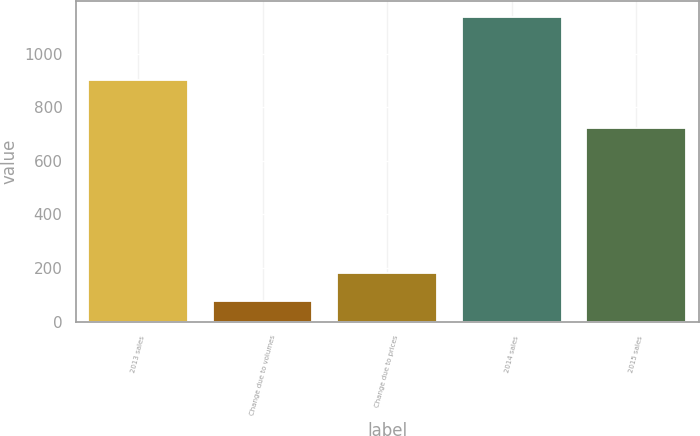Convert chart to OTSL. <chart><loc_0><loc_0><loc_500><loc_500><bar_chart><fcel>2013 sales<fcel>Change due to volumes<fcel>Change due to prices<fcel>2014 sales<fcel>2015 sales<nl><fcel>902<fcel>76<fcel>182.2<fcel>1138<fcel>722<nl></chart> 